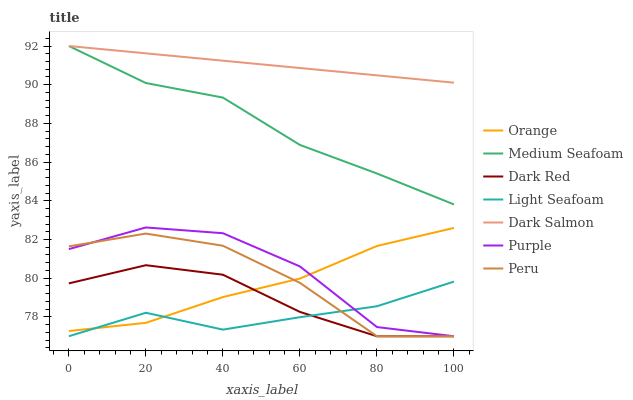Does Light Seafoam have the minimum area under the curve?
Answer yes or no. Yes. Does Dark Salmon have the maximum area under the curve?
Answer yes or no. Yes. Does Dark Red have the minimum area under the curve?
Answer yes or no. No. Does Dark Red have the maximum area under the curve?
Answer yes or no. No. Is Dark Salmon the smoothest?
Answer yes or no. Yes. Is Purple the roughest?
Answer yes or no. Yes. Is Dark Red the smoothest?
Answer yes or no. No. Is Dark Red the roughest?
Answer yes or no. No. Does Purple have the lowest value?
Answer yes or no. Yes. Does Dark Salmon have the lowest value?
Answer yes or no. No. Does Medium Seafoam have the highest value?
Answer yes or no. Yes. Does Dark Red have the highest value?
Answer yes or no. No. Is Dark Red less than Dark Salmon?
Answer yes or no. Yes. Is Dark Salmon greater than Dark Red?
Answer yes or no. Yes. Does Peru intersect Light Seafoam?
Answer yes or no. Yes. Is Peru less than Light Seafoam?
Answer yes or no. No. Is Peru greater than Light Seafoam?
Answer yes or no. No. Does Dark Red intersect Dark Salmon?
Answer yes or no. No. 